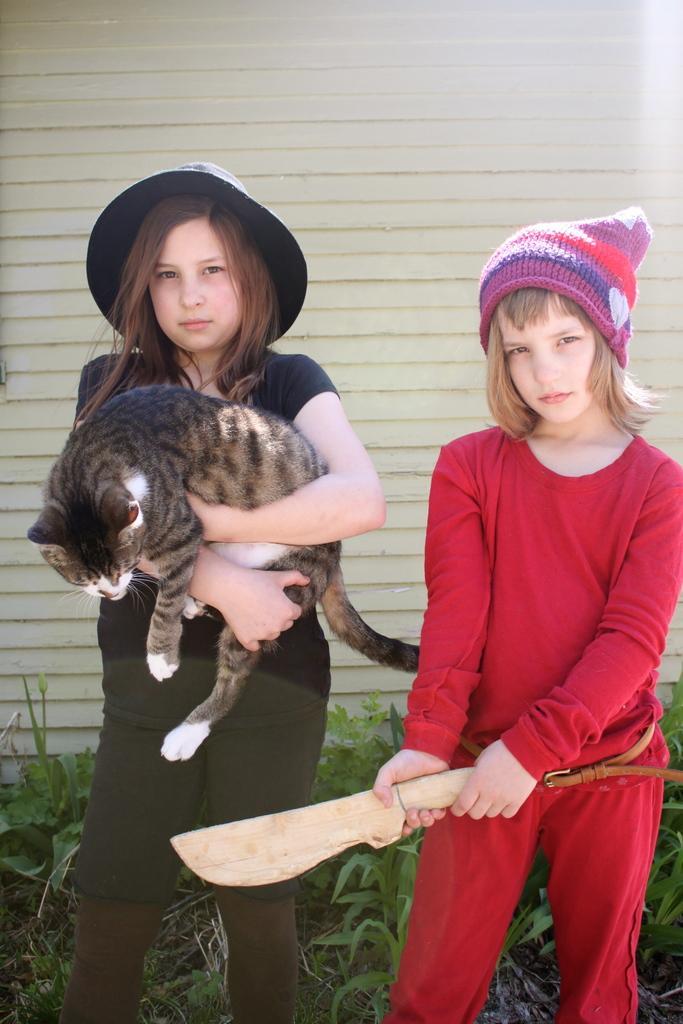Can you describe this image briefly? Here we can see two people are standing, and holding a cat in her hand, at side a girl is holding a knife in her hand, and here is the wall. 